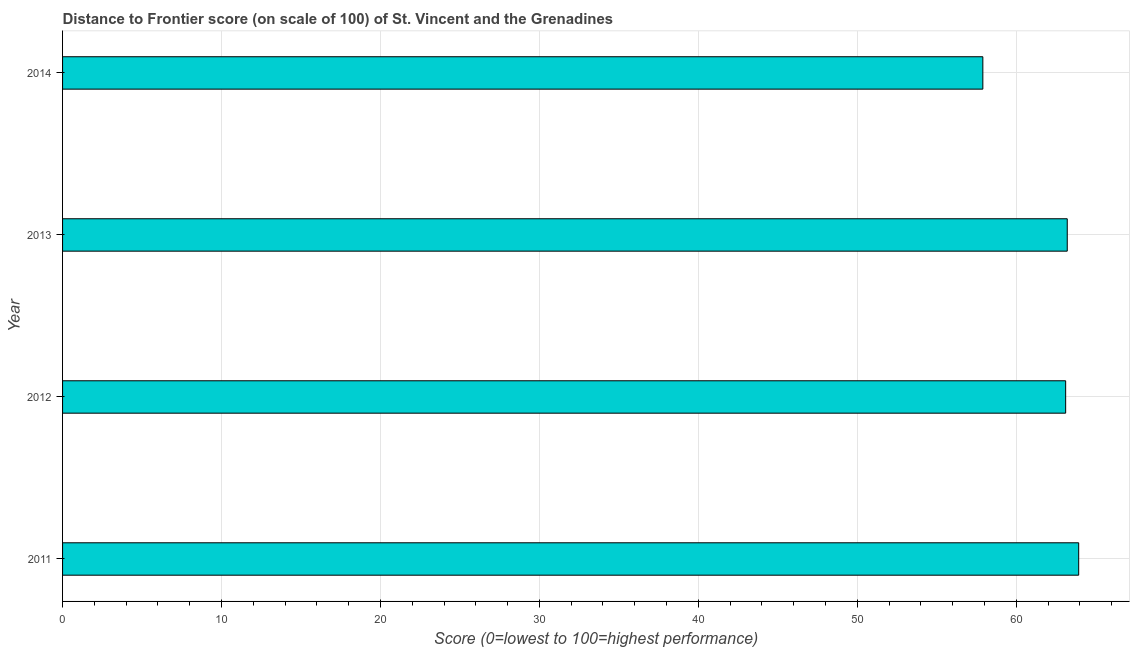Does the graph contain any zero values?
Your response must be concise. No. What is the title of the graph?
Your answer should be compact. Distance to Frontier score (on scale of 100) of St. Vincent and the Grenadines. What is the label or title of the X-axis?
Keep it short and to the point. Score (0=lowest to 100=highest performance). What is the label or title of the Y-axis?
Offer a terse response. Year. What is the distance to frontier score in 2013?
Provide a short and direct response. 63.21. Across all years, what is the maximum distance to frontier score?
Your answer should be compact. 63.93. Across all years, what is the minimum distance to frontier score?
Ensure brevity in your answer.  57.9. In which year was the distance to frontier score minimum?
Your answer should be very brief. 2014. What is the sum of the distance to frontier score?
Make the answer very short. 248.15. What is the difference between the distance to frontier score in 2011 and 2014?
Provide a short and direct response. 6.03. What is the average distance to frontier score per year?
Your response must be concise. 62.04. What is the median distance to frontier score?
Keep it short and to the point. 63.16. In how many years, is the distance to frontier score greater than 10 ?
Offer a terse response. 4. Do a majority of the years between 2011 and 2013 (inclusive) have distance to frontier score greater than 34 ?
Give a very brief answer. Yes. What is the ratio of the distance to frontier score in 2011 to that in 2014?
Keep it short and to the point. 1.1. What is the difference between the highest and the second highest distance to frontier score?
Offer a very short reply. 0.72. Is the sum of the distance to frontier score in 2011 and 2013 greater than the maximum distance to frontier score across all years?
Your answer should be very brief. Yes. What is the difference between the highest and the lowest distance to frontier score?
Make the answer very short. 6.03. In how many years, is the distance to frontier score greater than the average distance to frontier score taken over all years?
Provide a succinct answer. 3. How many bars are there?
Provide a short and direct response. 4. Are all the bars in the graph horizontal?
Give a very brief answer. Yes. How many years are there in the graph?
Your answer should be very brief. 4. What is the Score (0=lowest to 100=highest performance) of 2011?
Keep it short and to the point. 63.93. What is the Score (0=lowest to 100=highest performance) of 2012?
Your answer should be compact. 63.11. What is the Score (0=lowest to 100=highest performance) of 2013?
Your answer should be very brief. 63.21. What is the Score (0=lowest to 100=highest performance) in 2014?
Your response must be concise. 57.9. What is the difference between the Score (0=lowest to 100=highest performance) in 2011 and 2012?
Provide a succinct answer. 0.82. What is the difference between the Score (0=lowest to 100=highest performance) in 2011 and 2013?
Your answer should be compact. 0.72. What is the difference between the Score (0=lowest to 100=highest performance) in 2011 and 2014?
Provide a succinct answer. 6.03. What is the difference between the Score (0=lowest to 100=highest performance) in 2012 and 2013?
Offer a very short reply. -0.1. What is the difference between the Score (0=lowest to 100=highest performance) in 2012 and 2014?
Your answer should be compact. 5.21. What is the difference between the Score (0=lowest to 100=highest performance) in 2013 and 2014?
Make the answer very short. 5.31. What is the ratio of the Score (0=lowest to 100=highest performance) in 2011 to that in 2012?
Your answer should be very brief. 1.01. What is the ratio of the Score (0=lowest to 100=highest performance) in 2011 to that in 2014?
Offer a terse response. 1.1. What is the ratio of the Score (0=lowest to 100=highest performance) in 2012 to that in 2014?
Give a very brief answer. 1.09. What is the ratio of the Score (0=lowest to 100=highest performance) in 2013 to that in 2014?
Your answer should be compact. 1.09. 